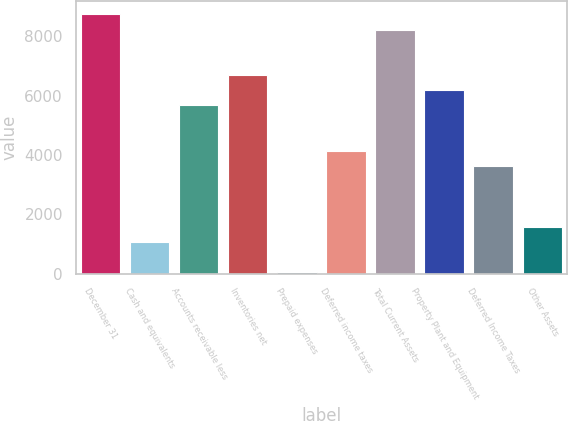<chart> <loc_0><loc_0><loc_500><loc_500><bar_chart><fcel>December 31<fcel>Cash and equivalents<fcel>Accounts receivable less<fcel>Inventories net<fcel>Prepaid expenses<fcel>Deferred income taxes<fcel>Total Current Assets<fcel>Property Plant and Equipment<fcel>Deferred Income Taxes<fcel>Other Assets<nl><fcel>8734.75<fcel>1066<fcel>5667.25<fcel>6689.75<fcel>43.5<fcel>4133.5<fcel>8223.5<fcel>6178.5<fcel>3622.25<fcel>1577.25<nl></chart> 